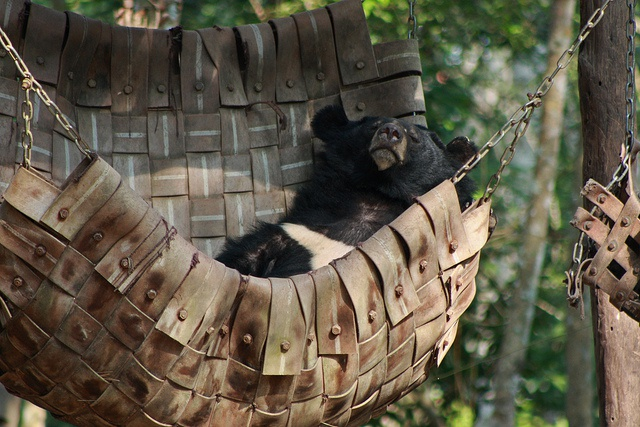Describe the objects in this image and their specific colors. I can see a bear in black, gray, and tan tones in this image. 